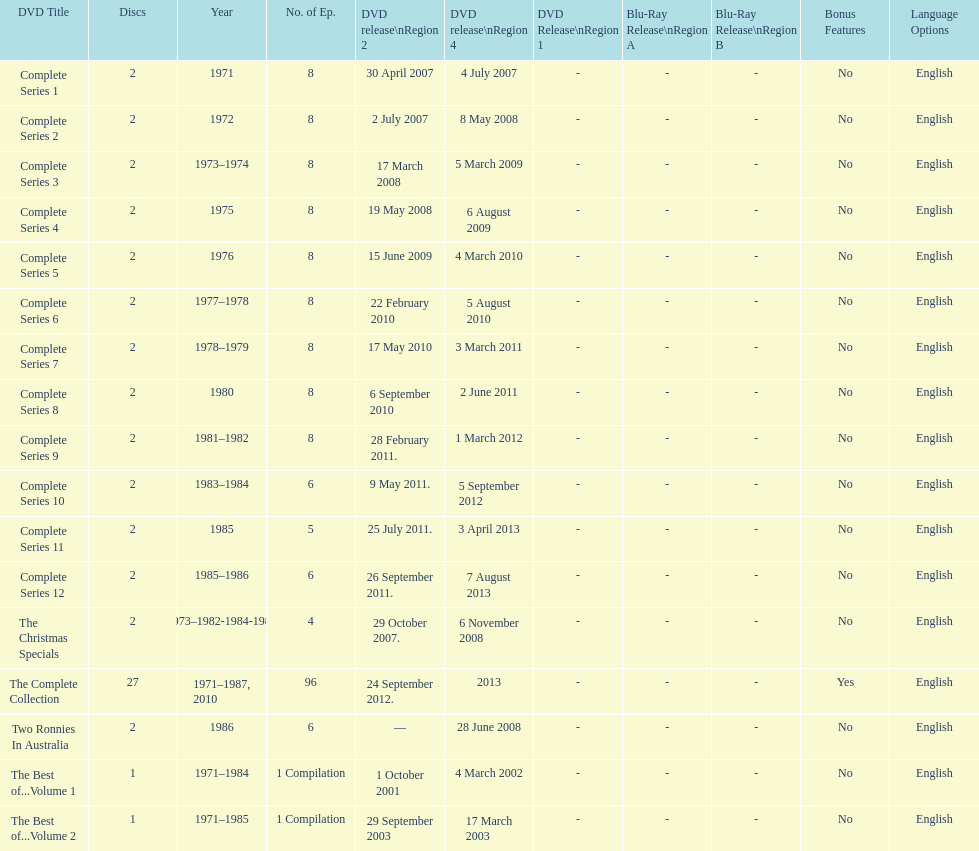The complete collection has 96 episodes, but the christmas specials only has how many episodes? 4. 